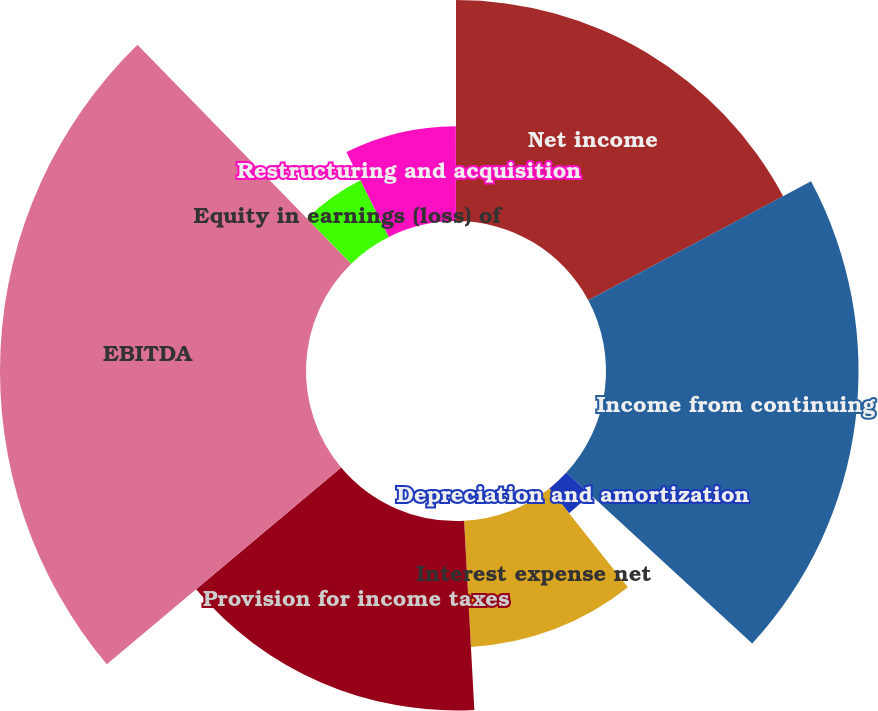<chart> <loc_0><loc_0><loc_500><loc_500><pie_chart><fcel>Net income<fcel>Income from continuing<fcel>Depreciation and amortization<fcel>Interest expense net<fcel>Provision for income taxes<fcel>EBITDA<fcel>Equity in earnings (loss) of<fcel>Restructuring and acquisition<fcel>Change in fair value of<nl><fcel>17.19%<fcel>19.65%<fcel>2.47%<fcel>9.83%<fcel>14.74%<fcel>23.81%<fcel>4.92%<fcel>7.38%<fcel>0.01%<nl></chart> 